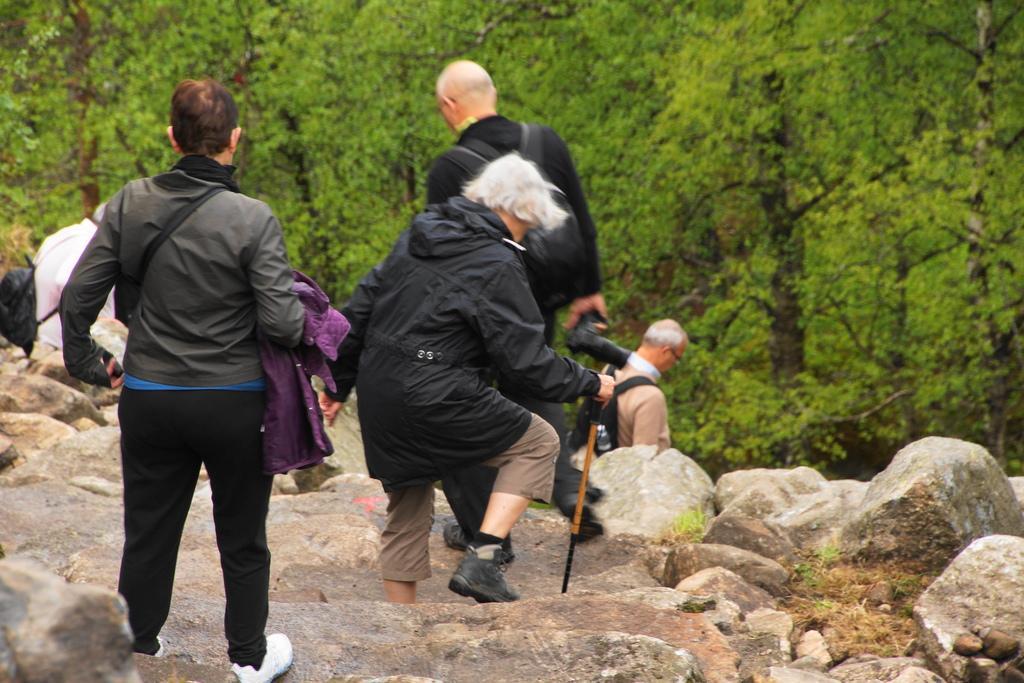How would you summarize this image in a sentence or two? In the center of the image there are many people walking. In the background of the image there are trees. In the bottom of the image there are stones. 